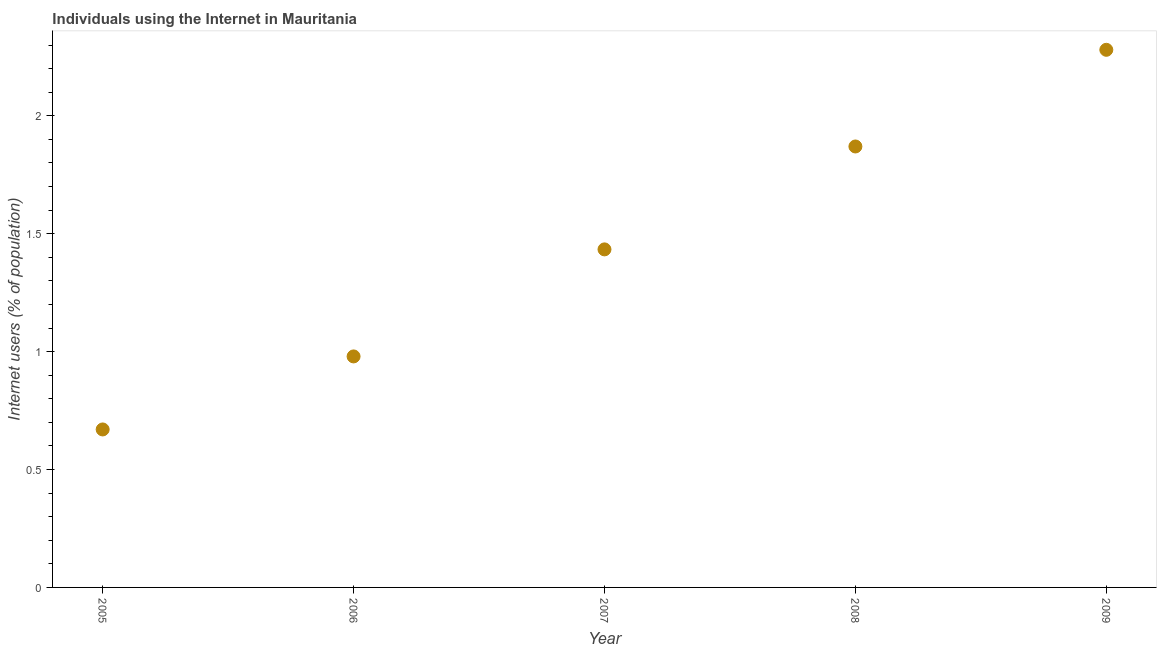What is the number of internet users in 2006?
Provide a short and direct response. 0.98. Across all years, what is the maximum number of internet users?
Make the answer very short. 2.28. Across all years, what is the minimum number of internet users?
Your answer should be very brief. 0.67. In which year was the number of internet users minimum?
Offer a terse response. 2005. What is the sum of the number of internet users?
Make the answer very short. 7.23. What is the difference between the number of internet users in 2005 and 2008?
Offer a terse response. -1.2. What is the average number of internet users per year?
Make the answer very short. 1.45. What is the median number of internet users?
Your response must be concise. 1.43. What is the ratio of the number of internet users in 2005 to that in 2008?
Offer a very short reply. 0.36. What is the difference between the highest and the second highest number of internet users?
Provide a succinct answer. 0.41. Is the sum of the number of internet users in 2008 and 2009 greater than the maximum number of internet users across all years?
Keep it short and to the point. Yes. What is the difference between the highest and the lowest number of internet users?
Give a very brief answer. 1.61. In how many years, is the number of internet users greater than the average number of internet users taken over all years?
Keep it short and to the point. 2. Does the number of internet users monotonically increase over the years?
Give a very brief answer. Yes. How many years are there in the graph?
Offer a very short reply. 5. What is the difference between two consecutive major ticks on the Y-axis?
Give a very brief answer. 0.5. Are the values on the major ticks of Y-axis written in scientific E-notation?
Provide a short and direct response. No. Does the graph contain grids?
Your answer should be very brief. No. What is the title of the graph?
Ensure brevity in your answer.  Individuals using the Internet in Mauritania. What is the label or title of the X-axis?
Your response must be concise. Year. What is the label or title of the Y-axis?
Offer a terse response. Internet users (% of population). What is the Internet users (% of population) in 2005?
Offer a very short reply. 0.67. What is the Internet users (% of population) in 2006?
Offer a very short reply. 0.98. What is the Internet users (% of population) in 2007?
Your answer should be very brief. 1.43. What is the Internet users (% of population) in 2008?
Give a very brief answer. 1.87. What is the Internet users (% of population) in 2009?
Your response must be concise. 2.28. What is the difference between the Internet users (% of population) in 2005 and 2006?
Your answer should be compact. -0.31. What is the difference between the Internet users (% of population) in 2005 and 2007?
Your answer should be very brief. -0.76. What is the difference between the Internet users (% of population) in 2005 and 2008?
Provide a short and direct response. -1.2. What is the difference between the Internet users (% of population) in 2005 and 2009?
Your answer should be compact. -1.61. What is the difference between the Internet users (% of population) in 2006 and 2007?
Make the answer very short. -0.45. What is the difference between the Internet users (% of population) in 2006 and 2008?
Provide a short and direct response. -0.89. What is the difference between the Internet users (% of population) in 2006 and 2009?
Your answer should be compact. -1.3. What is the difference between the Internet users (% of population) in 2007 and 2008?
Give a very brief answer. -0.44. What is the difference between the Internet users (% of population) in 2007 and 2009?
Provide a succinct answer. -0.85. What is the difference between the Internet users (% of population) in 2008 and 2009?
Offer a terse response. -0.41. What is the ratio of the Internet users (% of population) in 2005 to that in 2006?
Offer a very short reply. 0.68. What is the ratio of the Internet users (% of population) in 2005 to that in 2007?
Offer a terse response. 0.47. What is the ratio of the Internet users (% of population) in 2005 to that in 2008?
Keep it short and to the point. 0.36. What is the ratio of the Internet users (% of population) in 2005 to that in 2009?
Offer a terse response. 0.29. What is the ratio of the Internet users (% of population) in 2006 to that in 2007?
Your answer should be very brief. 0.68. What is the ratio of the Internet users (% of population) in 2006 to that in 2008?
Make the answer very short. 0.52. What is the ratio of the Internet users (% of population) in 2006 to that in 2009?
Keep it short and to the point. 0.43. What is the ratio of the Internet users (% of population) in 2007 to that in 2008?
Your answer should be compact. 0.77. What is the ratio of the Internet users (% of population) in 2007 to that in 2009?
Your answer should be compact. 0.63. What is the ratio of the Internet users (% of population) in 2008 to that in 2009?
Provide a short and direct response. 0.82. 